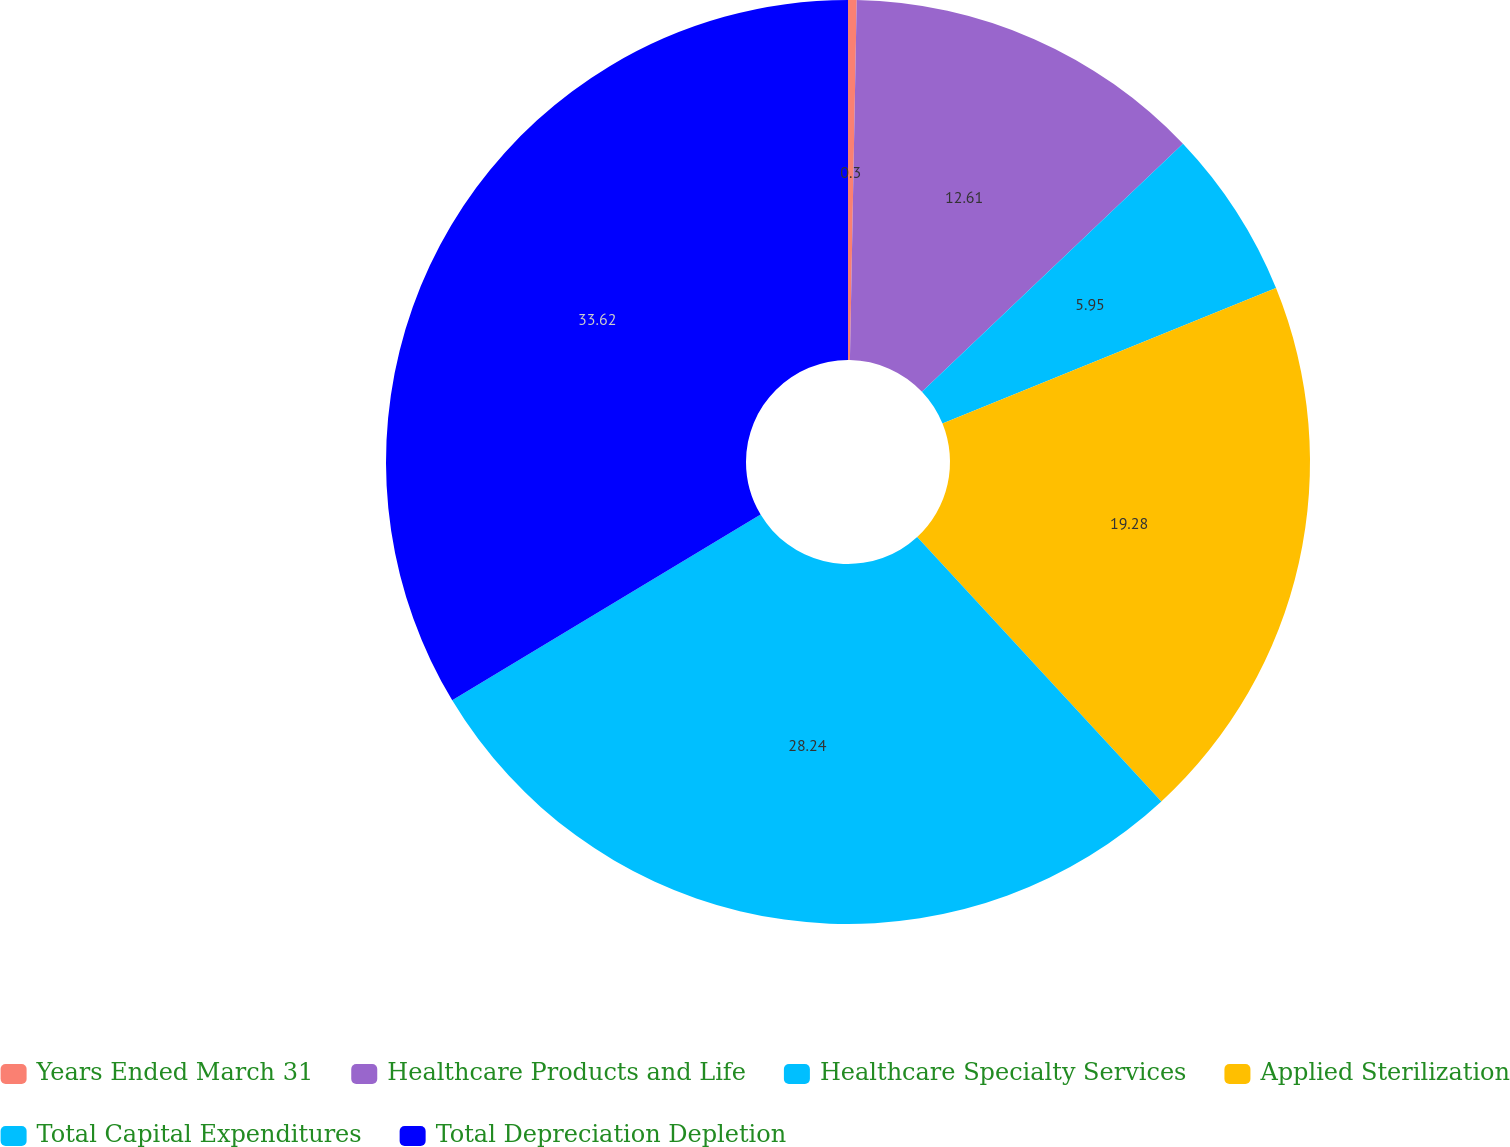<chart> <loc_0><loc_0><loc_500><loc_500><pie_chart><fcel>Years Ended March 31<fcel>Healthcare Products and Life<fcel>Healthcare Specialty Services<fcel>Applied Sterilization<fcel>Total Capital Expenditures<fcel>Total Depreciation Depletion<nl><fcel>0.3%<fcel>12.61%<fcel>5.95%<fcel>19.28%<fcel>28.24%<fcel>33.63%<nl></chart> 